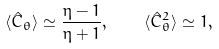<formula> <loc_0><loc_0><loc_500><loc_500>\langle \hat { C } _ { \theta } \rangle \simeq \frac { \eta - 1 } { \eta + 1 } , \quad \langle \hat { C } _ { \theta } ^ { 2 } \rangle \simeq 1 ,</formula> 